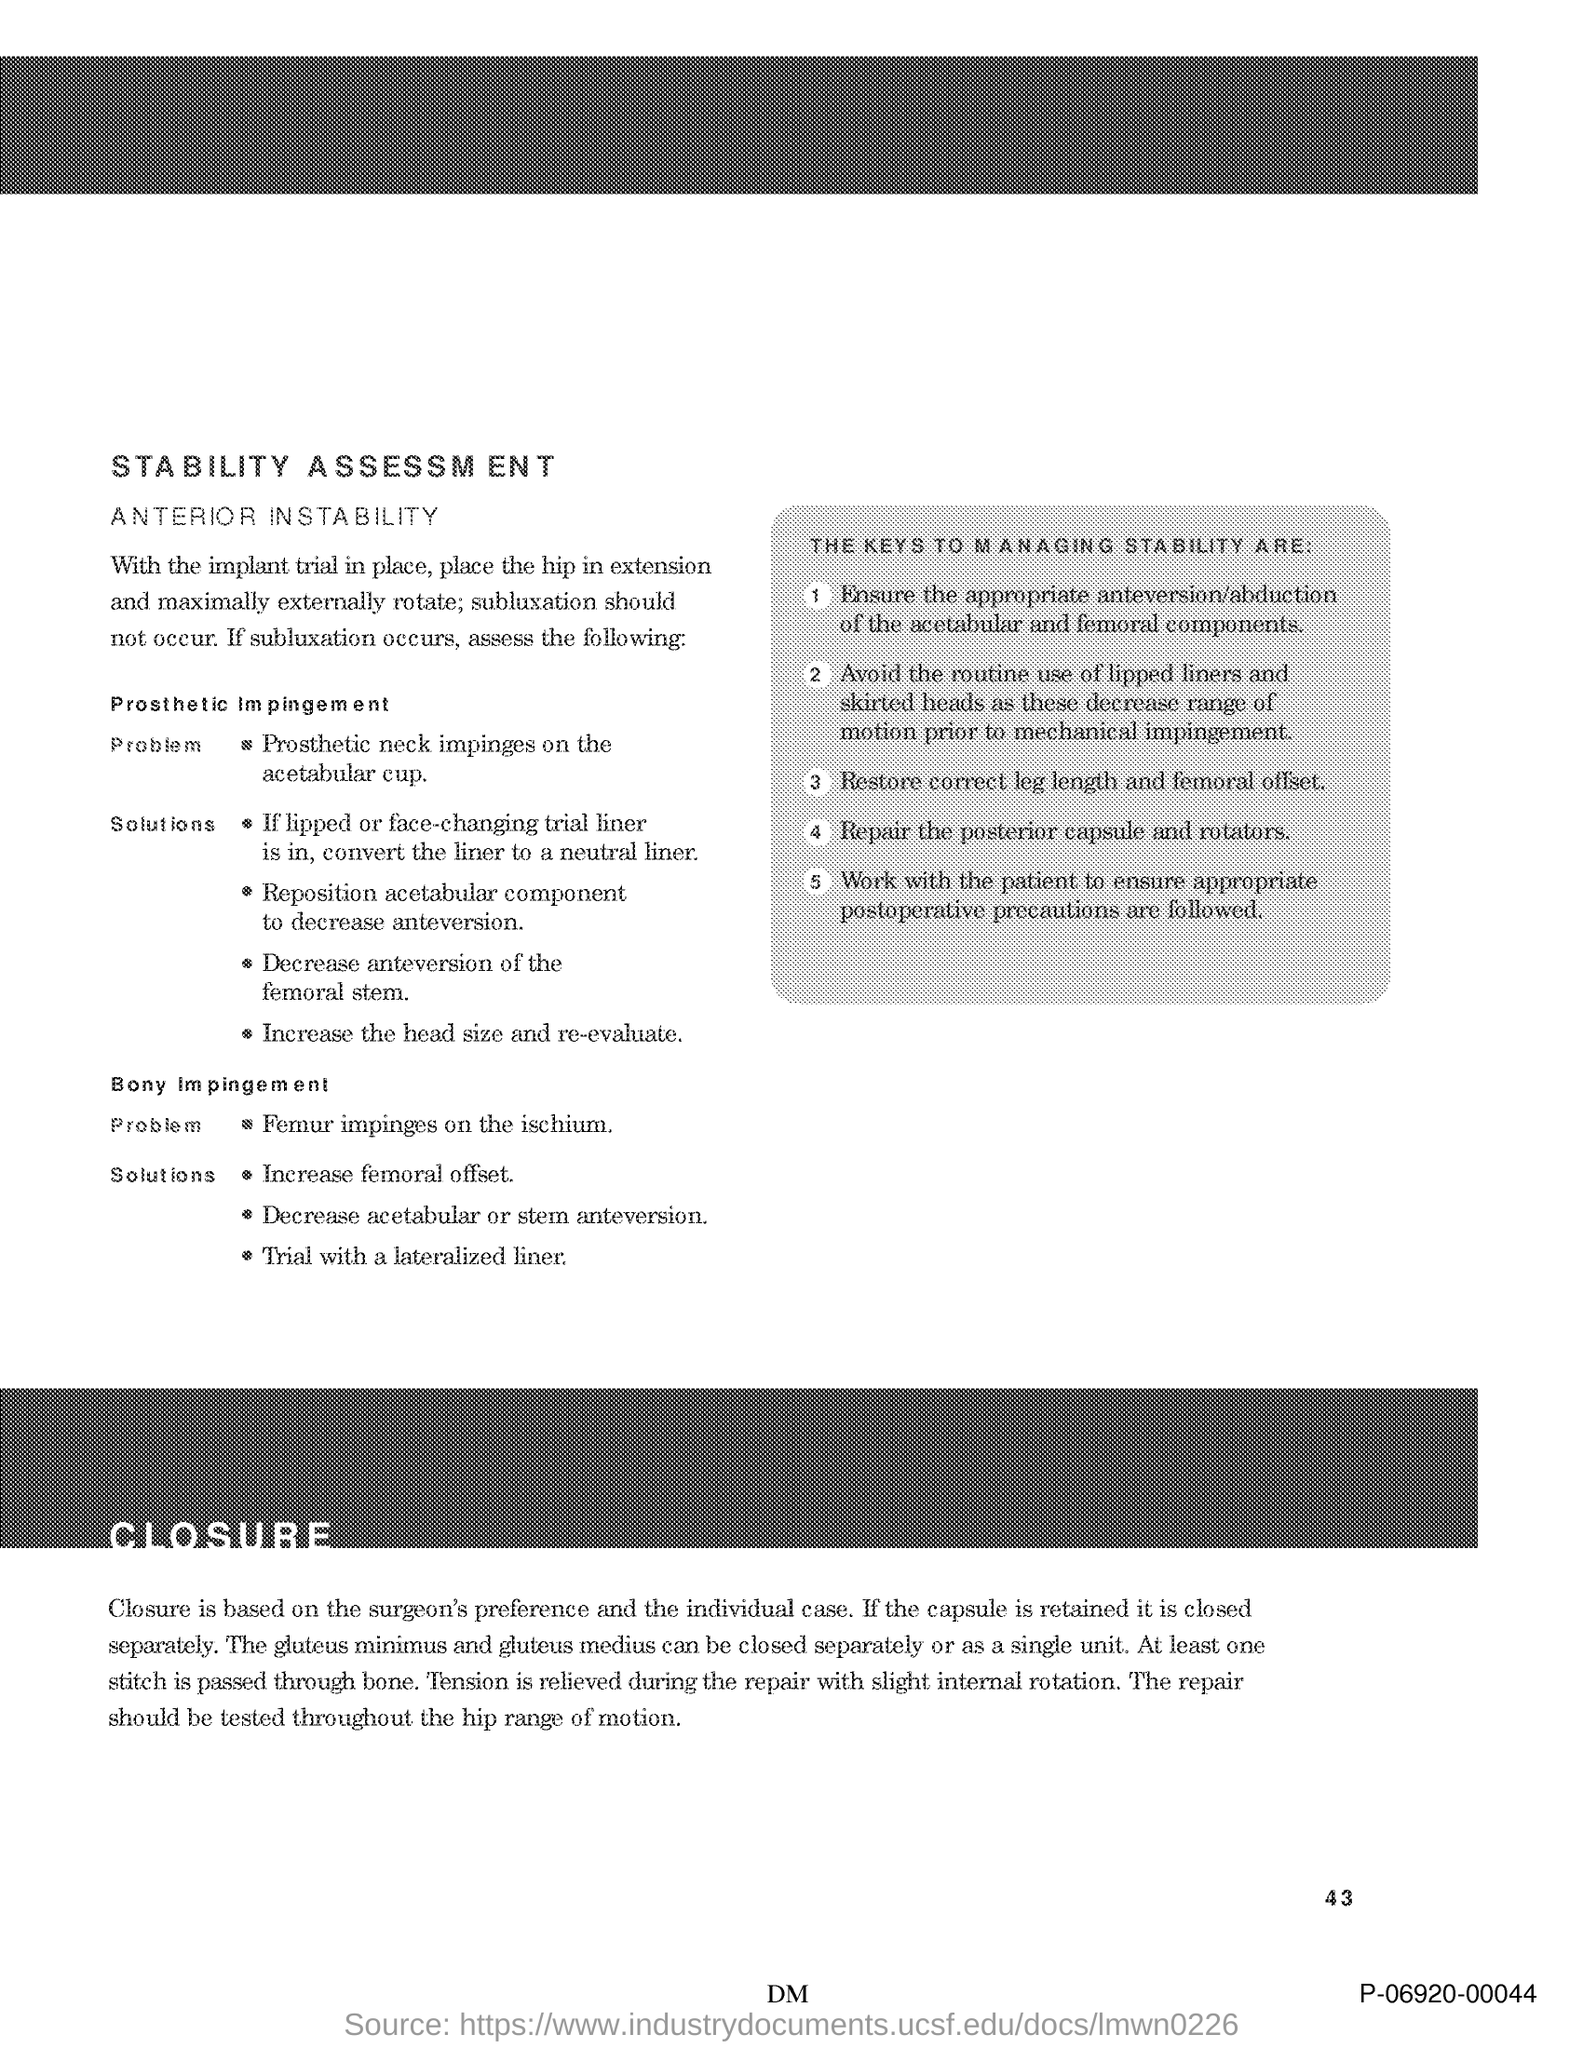What is the number at bottom right side of the page?
Provide a short and direct response. 43. 